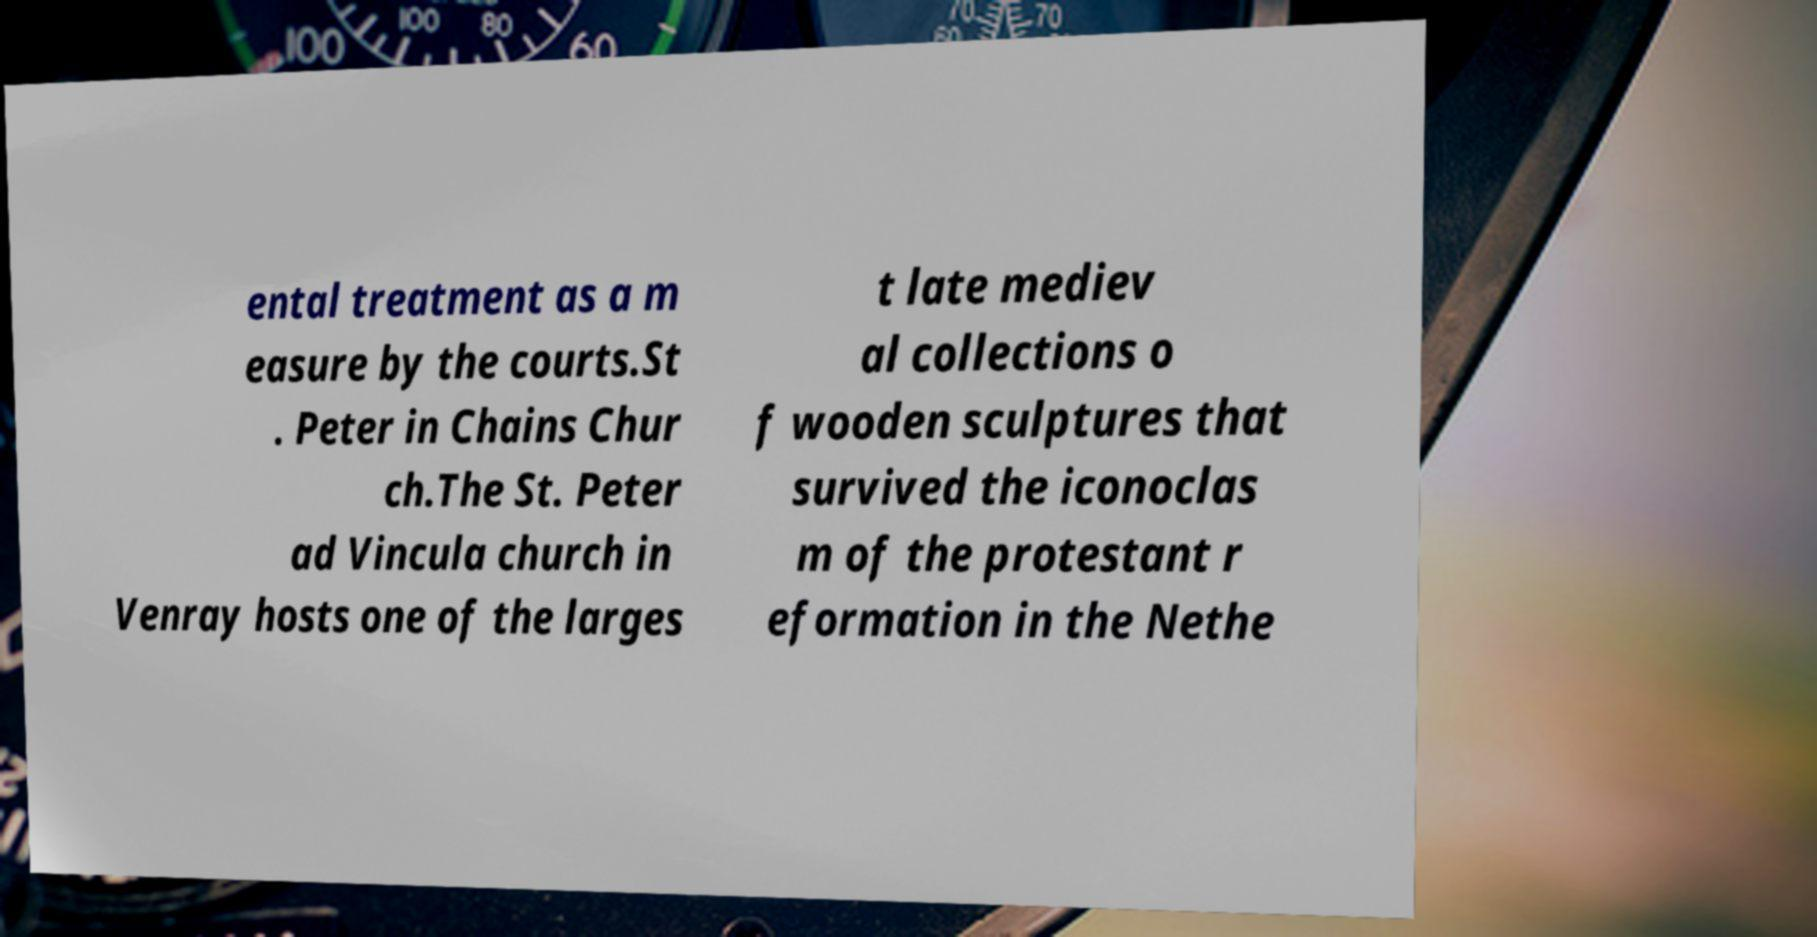I need the written content from this picture converted into text. Can you do that? ental treatment as a m easure by the courts.St . Peter in Chains Chur ch.The St. Peter ad Vincula church in Venray hosts one of the larges t late mediev al collections o f wooden sculptures that survived the iconoclas m of the protestant r eformation in the Nethe 